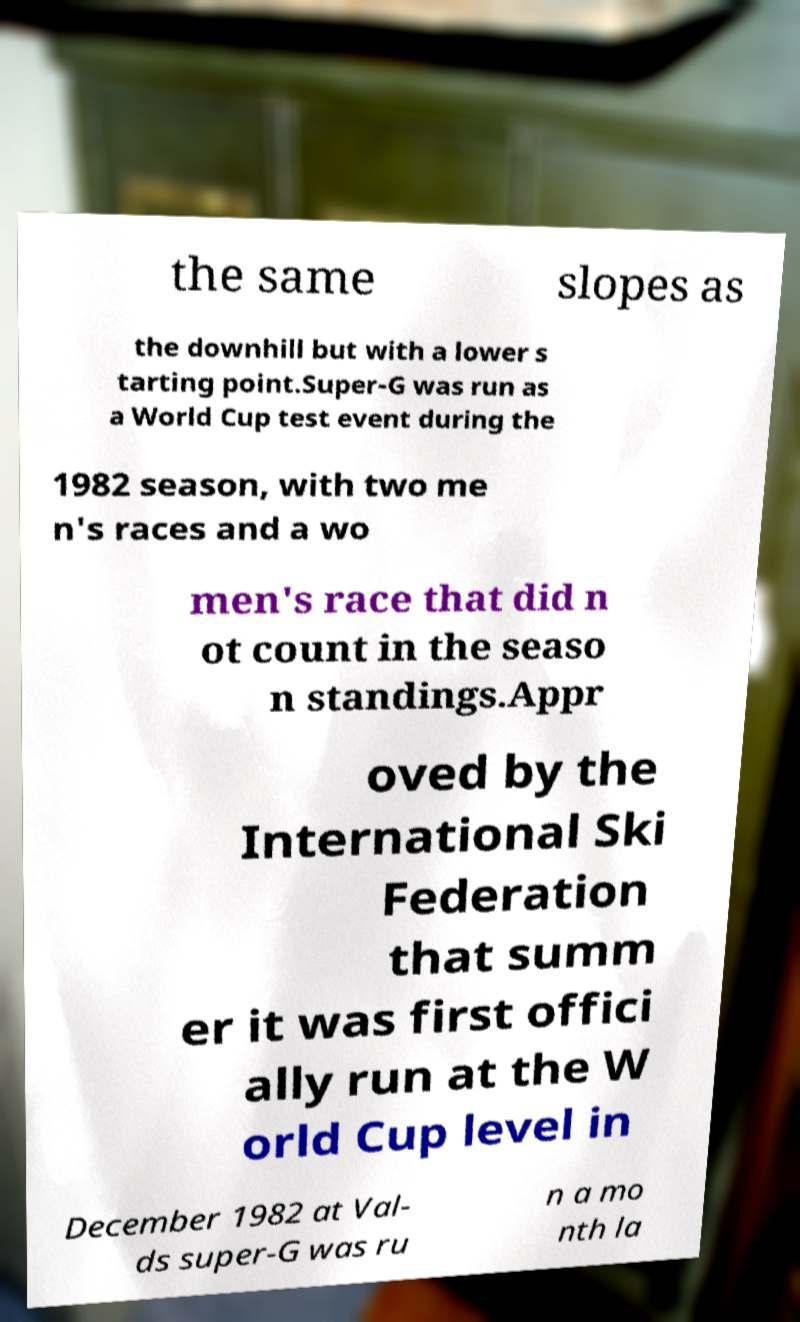What messages or text are displayed in this image? I need them in a readable, typed format. the same slopes as the downhill but with a lower s tarting point.Super-G was run as a World Cup test event during the 1982 season, with two me n's races and a wo men's race that did n ot count in the seaso n standings.Appr oved by the International Ski Federation that summ er it was first offici ally run at the W orld Cup level in December 1982 at Val- ds super-G was ru n a mo nth la 